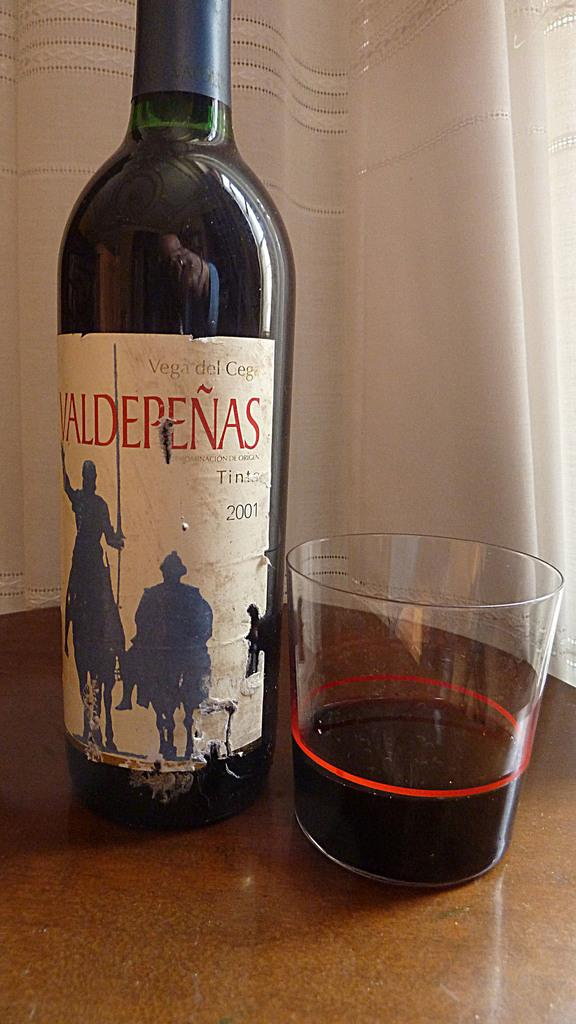<image>
Provide a brief description of the given image. A bottle of 2001 Valdepeñas wine next to a glass. 